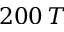Convert formula to latex. <formula><loc_0><loc_0><loc_500><loc_500>2 0 0 \, T</formula> 